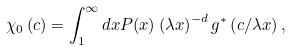Convert formula to latex. <formula><loc_0><loc_0><loc_500><loc_500>\chi _ { 0 } \left ( c \right ) = \int _ { 1 } ^ { \infty } d x P ( x ) \left ( \lambda x \right ) ^ { - d } g ^ { \ast } \left ( c / \lambda x \right ) ,</formula> 